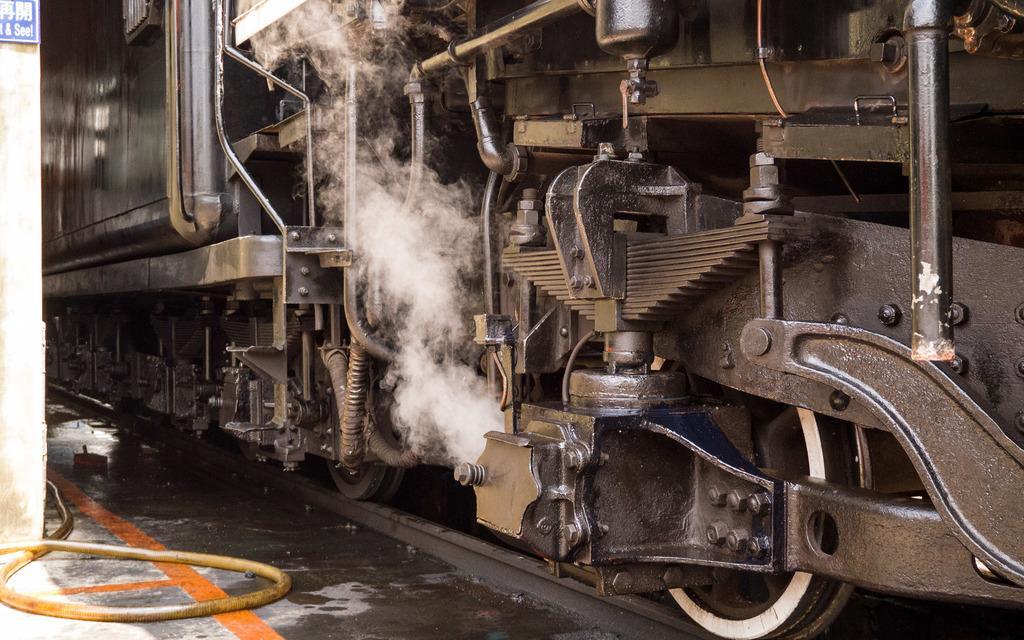Describe this image in one or two sentences. This image is taken outdoors. At the bottom of the image there is a floor and there is a pipe on the floor. On the left side of the image there is a wall with a board on it. In this image there is a train on the track. 